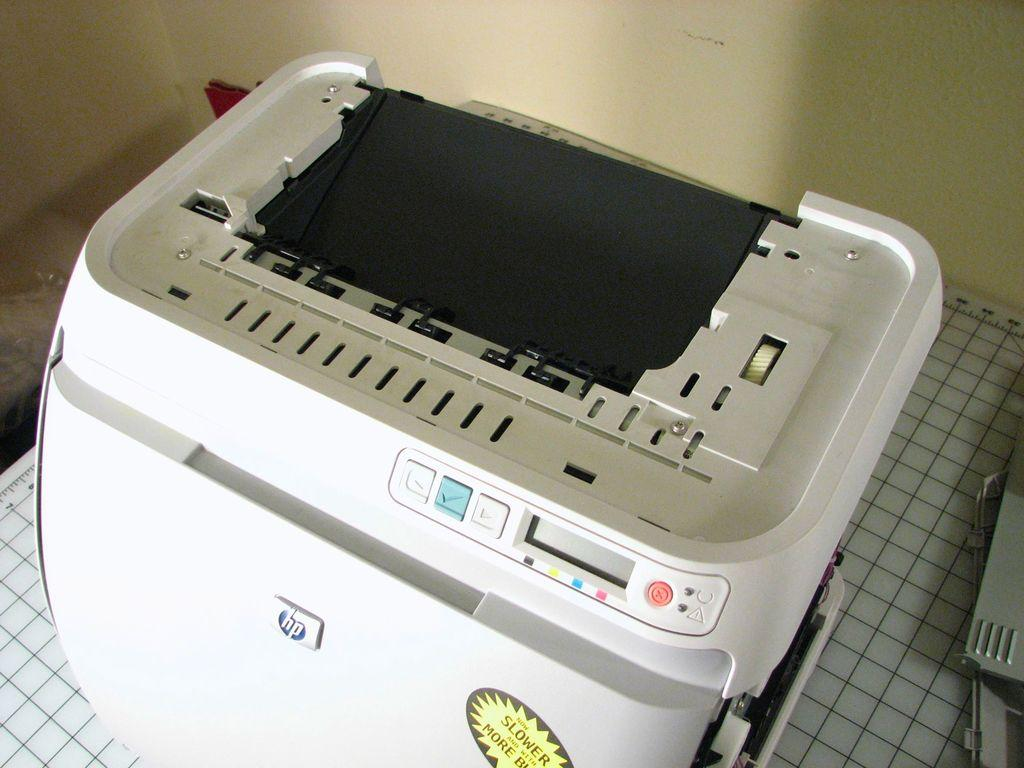What type of device is present in the image? There is a printer in the image. What is placed on the cutting mat in the image? There is an object on a cutting mat in the image. What can be seen in the background of the image? There are walls visible in the background of the image. What type of toys can be seen hanging from a hook in the image? There is no hook or toys present in the image. 